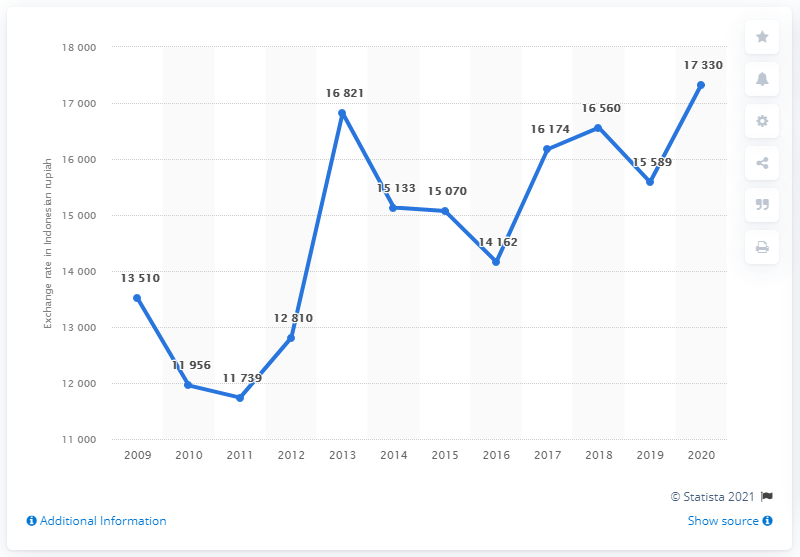Specify some key components in this picture. The average exchange rate from Indonesian rupiah to Euros in 2020 was 17,330. In 2020, the average exchange rate from Indonesian rupiah to Euros was 17,330 Indonesian rupiah to one Euro. 